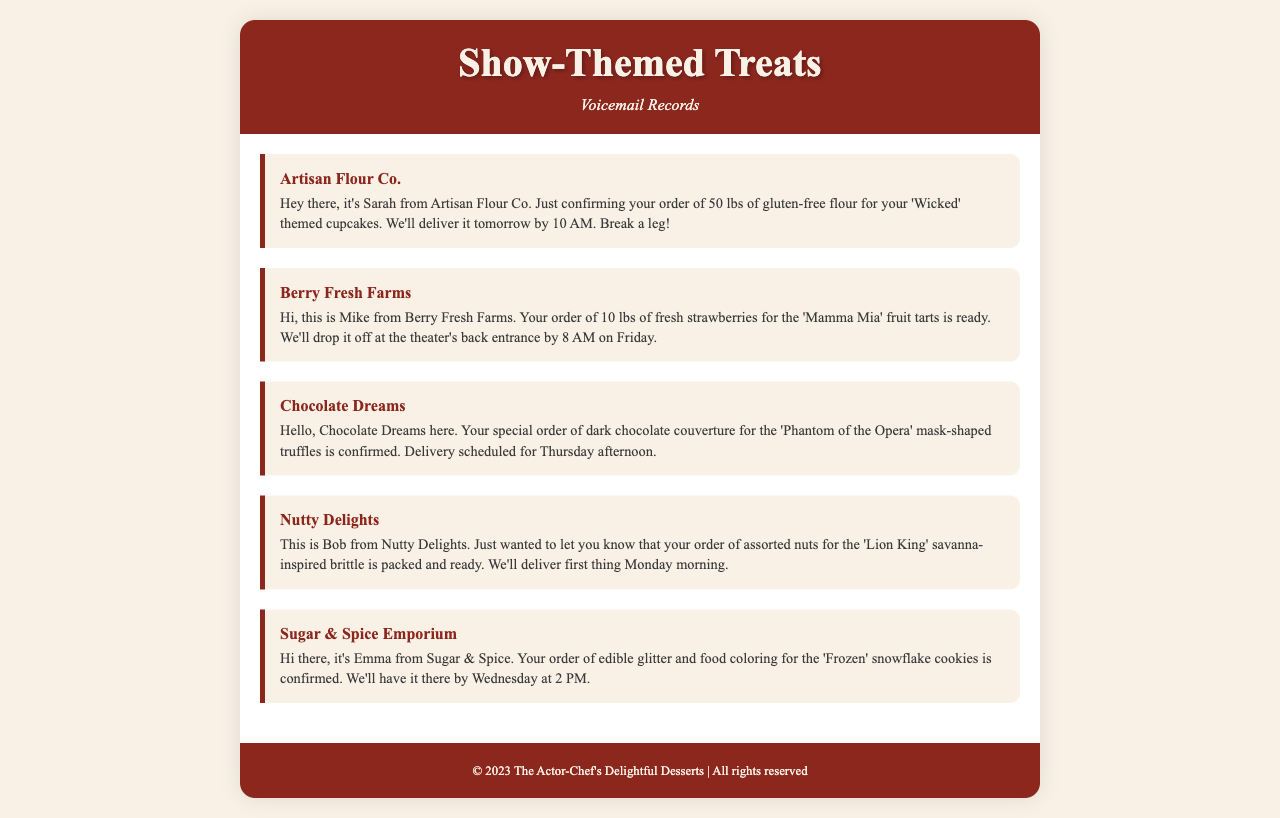What is the name of the supplier for gluten-free flour? The document states that the supplier for gluten-free flour is Artisan Flour Co.
Answer: Artisan Flour Co When will the strawberries be delivered? According to the voicemail from Berry Fresh Farms, the strawberries will be delivered by 8 AM on Friday.
Answer: 8 AM on Friday How many pounds of dark chocolate couverture were ordered? The order confirmation from Chocolate Dreams mentions a special order of dark chocolate couverture without specifying a weight, implying a standard order quantity.
Answer: Not specified Who confirmed the order for edible glitter and food coloring? The voicemail from Sugar & Spice Emporium indicates that Emma confirmed the order for edible glitter and food coloring.
Answer: Emma Which themed treat requires assorted nuts according to the document? The voicemail from Nutty Delights states the assorted nuts are for the 'Lion King' savanna-inspired brittle.
Answer: 'Lion King' What time will the gluten-free flour be delivered? The voicemail specifies that the gluten-free flour will be delivered by 10 AM.
Answer: 10 AM How many pounds of fresh strawberries were ordered? The voicemail from Berry Fresh Farms indicates that 10 lbs of fresh strawberries were ordered.
Answer: 10 lbs What type of dessert is associated with the order from Chocolate Dreams? The order from Chocolate Dreams is for mask-shaped truffles related to 'Phantom of the Opera.'
Answer: mask-shaped truffles What is the theme of the cupcakes receiving gluten-free flour? The voicemail states the gluten-free flour is for 'Wicked' themed cupcakes.
Answer: 'Wicked' 